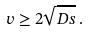<formula> <loc_0><loc_0><loc_500><loc_500>v \geq 2 \sqrt { D s } \, .</formula> 